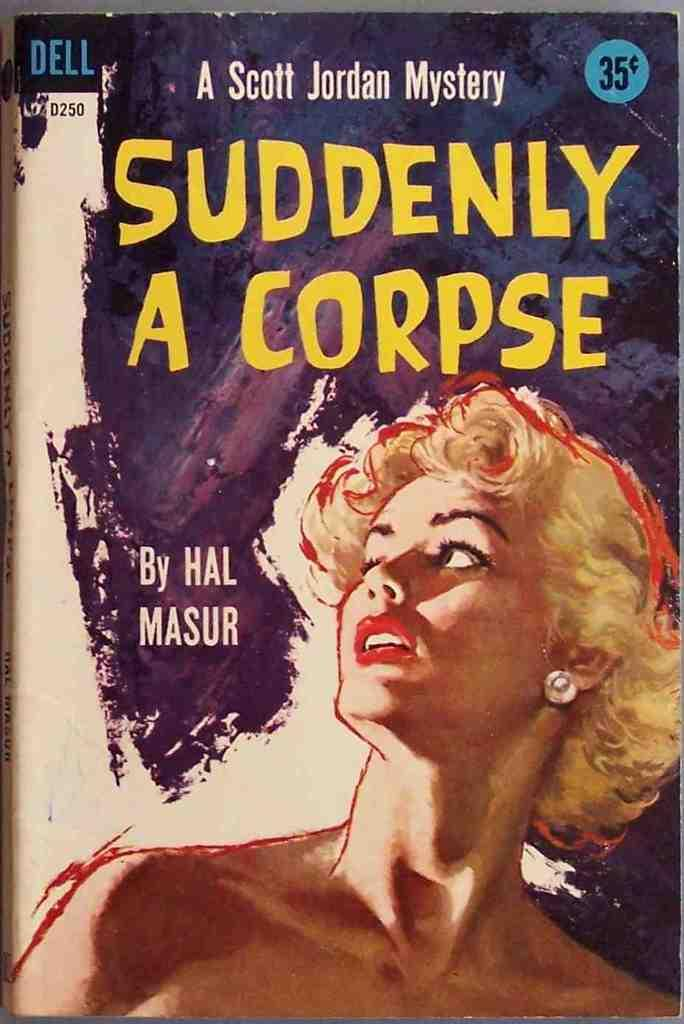What is featured on the poster in the image? There is a poster with information in the image. Can you describe the woman in the image? There is a woman with short hair in the image. How many bears can be seen interacting with the woman in the image? There are no bears present in the image. What type of ants are crawling on the poster in the image? There are no ants present on the poster or in the image. 